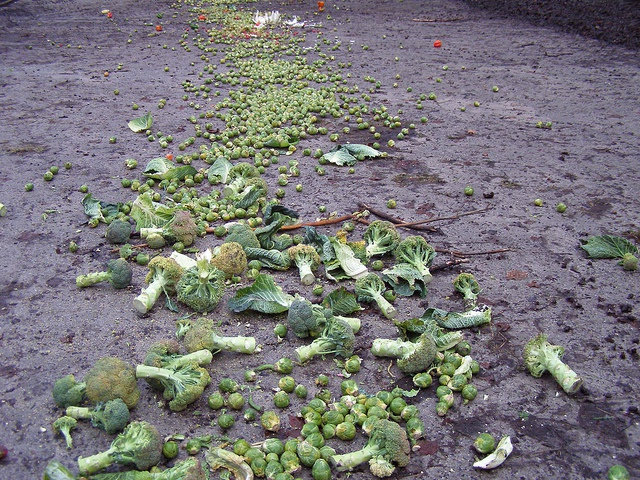Describe the objects in this image and their specific colors. I can see broccoli in black, gray, darkgray, and olive tones, broccoli in black, gray, and darkgray tones, broccoli in black, gray, olive, and darkgreen tones, broccoli in black, gray, olive, and lightgreen tones, and broccoli in black, gray, olive, and darkgray tones in this image. 